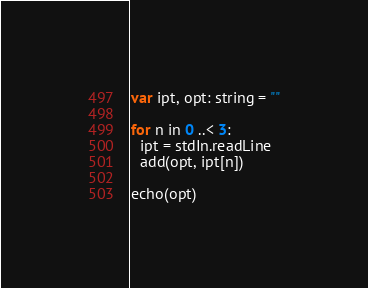Convert code to text. <code><loc_0><loc_0><loc_500><loc_500><_Nim_>var ipt, opt: string = ""

for n in 0 ..< 3:
  ipt = stdIn.readLine
  add(opt, ipt[n])

echo(opt)
</code> 